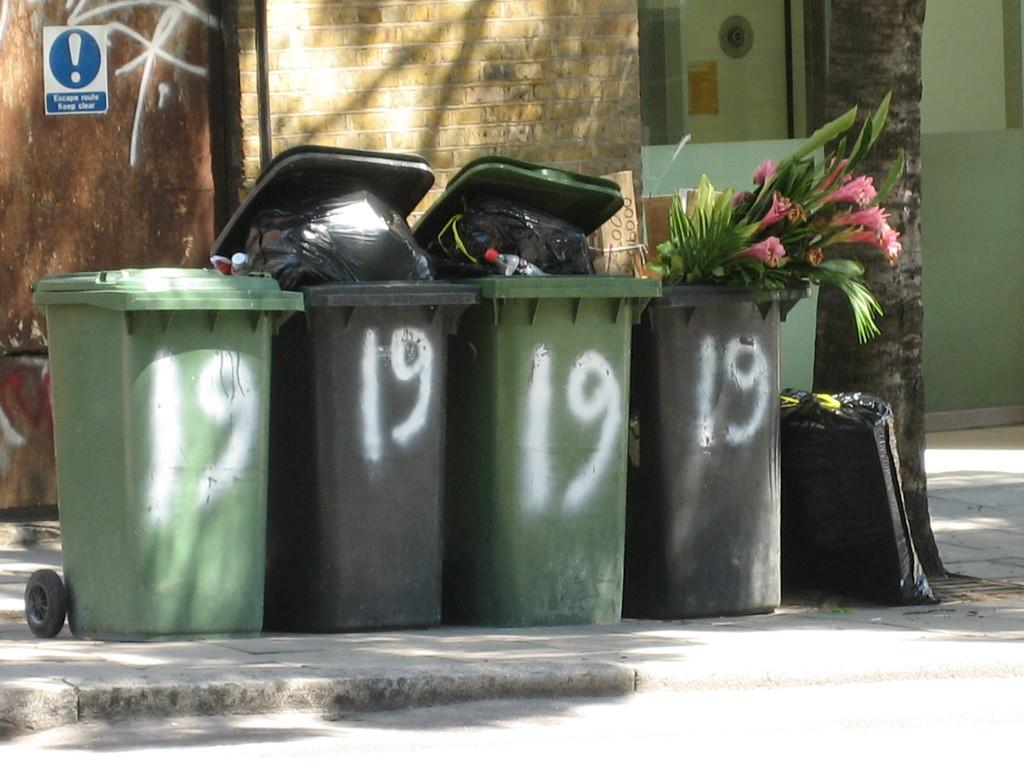<image>
Present a compact description of the photo's key features. Four trash cans line the street with the number 19 written on all of them 